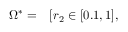Convert formula to latex. <formula><loc_0><loc_0><loc_500><loc_500>\begin{array} { r l } { \Omega ^ { * } = } & [ r _ { 2 } \in [ 0 . 1 , 1 ] , } \end{array}</formula> 